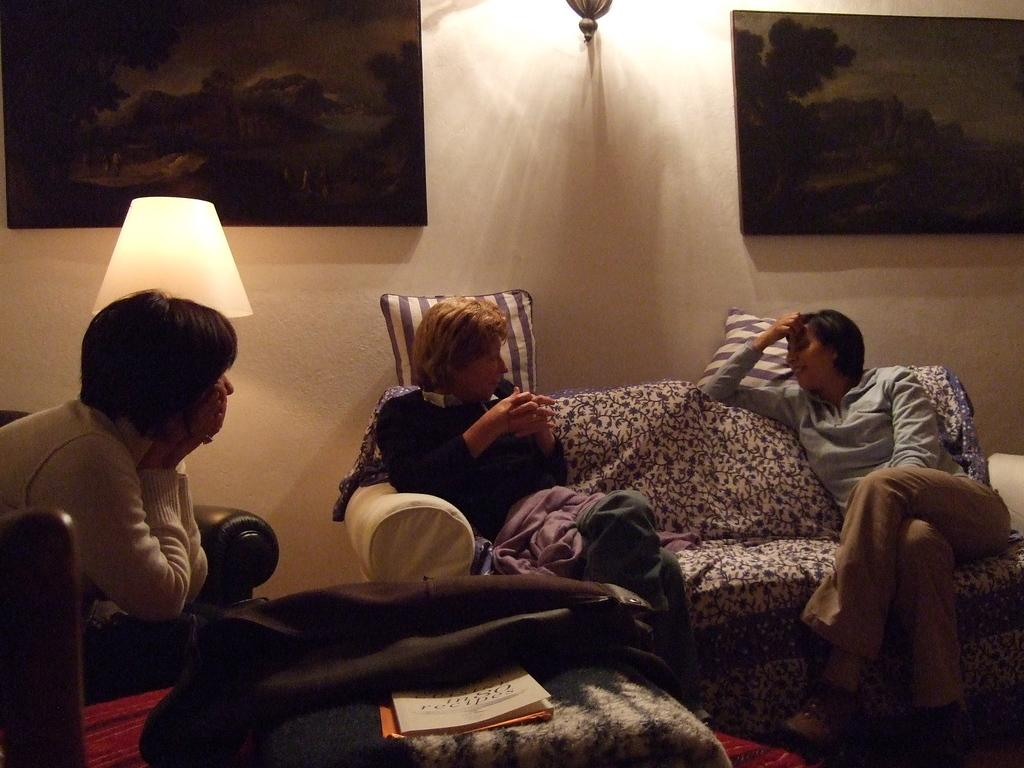What is the primary location of the women in the image? The women are sitting on a sofa and a chair. How many women are present in the image? The number of women is not specified in the facts, so we cannot definitively answer this question. What type of furniture is the women sitting on? The women are sitting on a sofa and a chair. What type of blade is being used by the women in the image? There is no blade present in the image; the women are sitting on a sofa and a chair. 